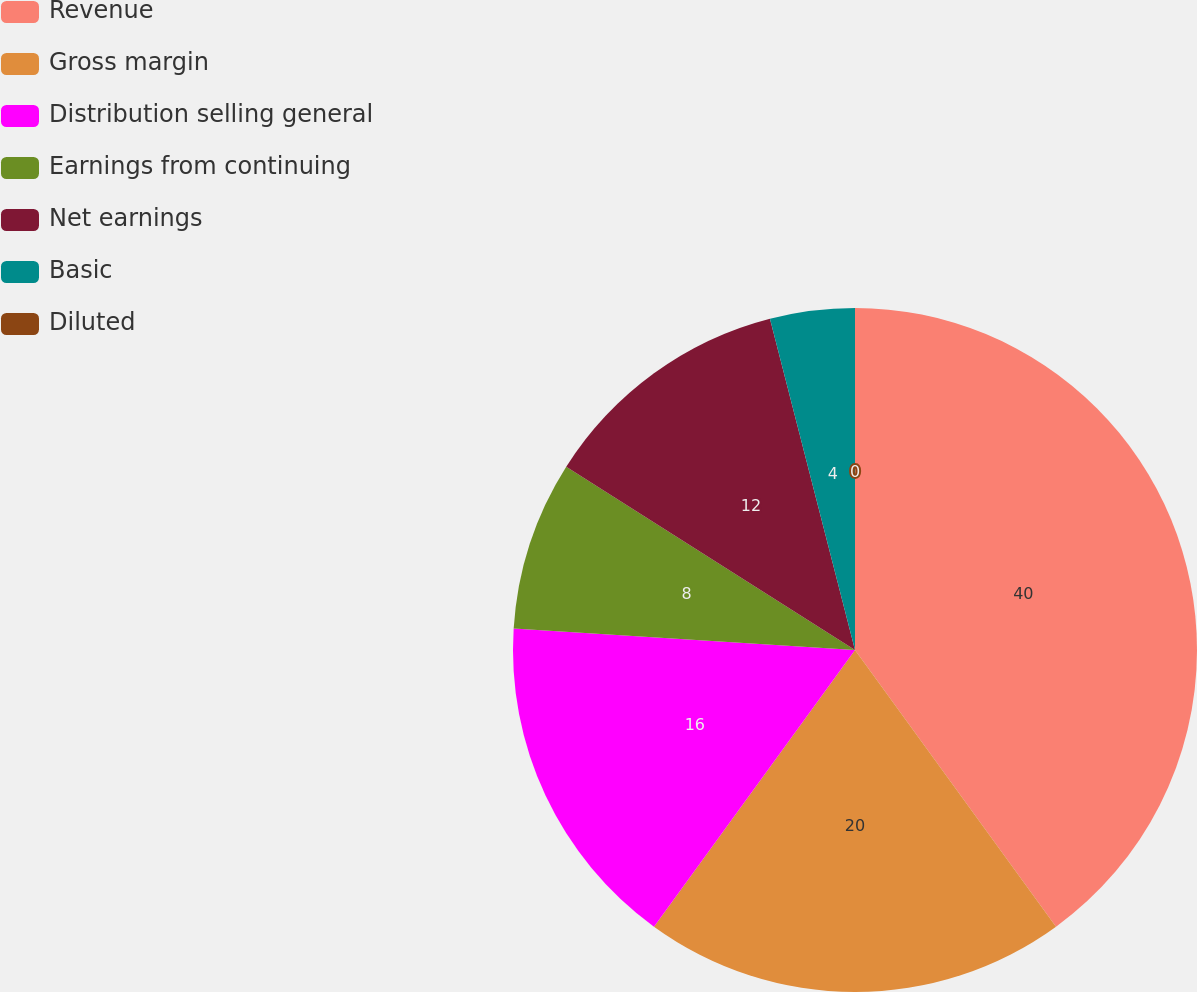Convert chart. <chart><loc_0><loc_0><loc_500><loc_500><pie_chart><fcel>Revenue<fcel>Gross margin<fcel>Distribution selling general<fcel>Earnings from continuing<fcel>Net earnings<fcel>Basic<fcel>Diluted<nl><fcel>40.0%<fcel>20.0%<fcel>16.0%<fcel>8.0%<fcel>12.0%<fcel>4.0%<fcel>0.0%<nl></chart> 